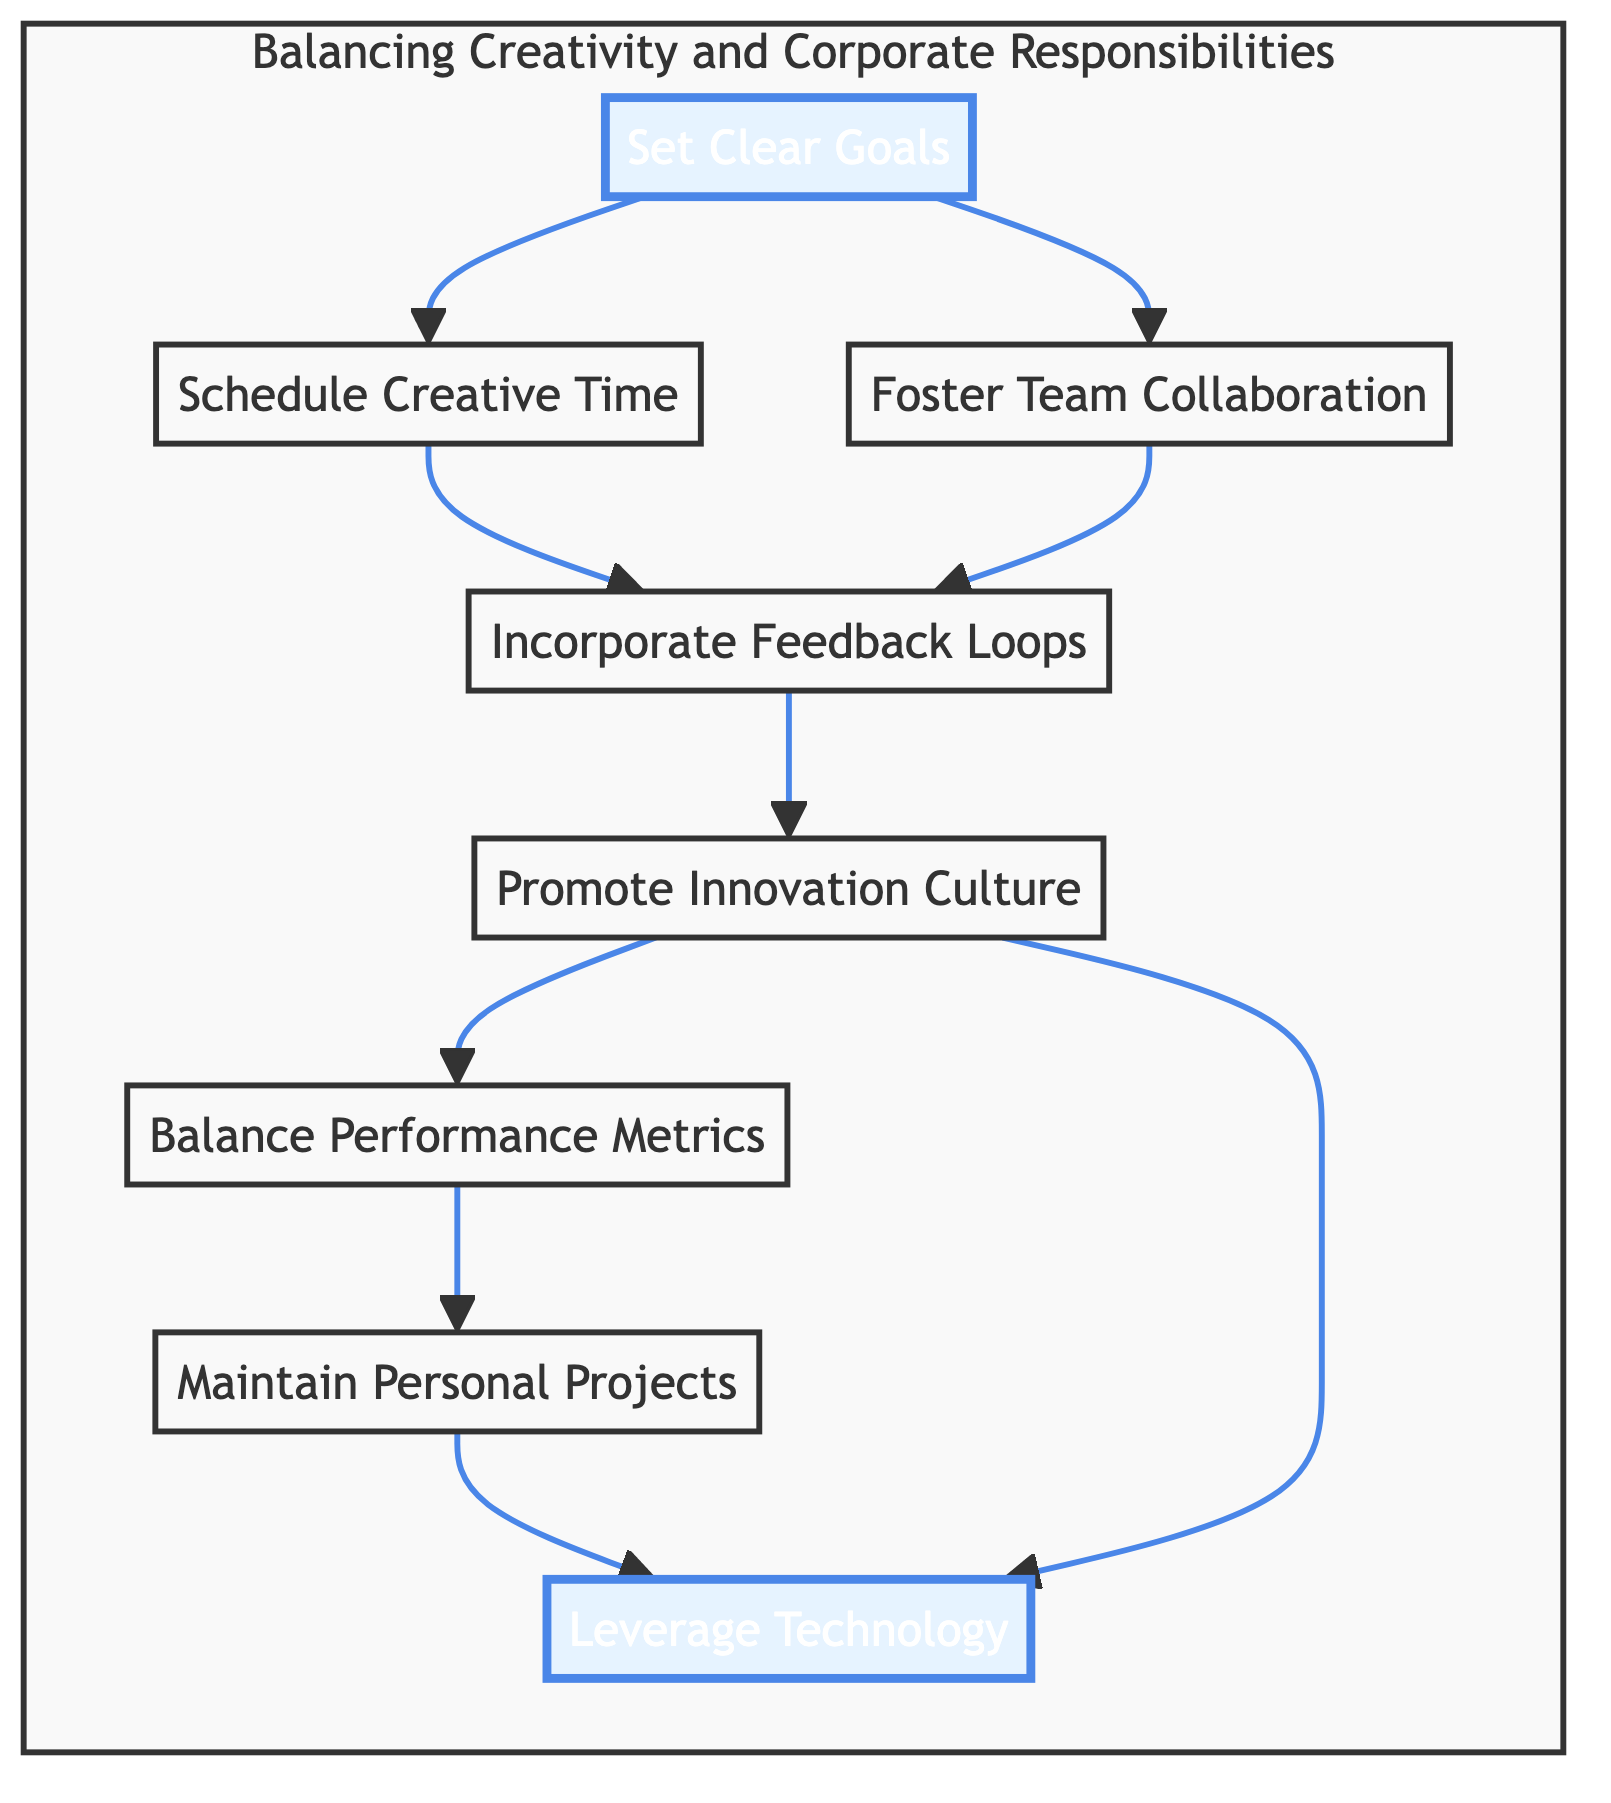What is the first step in the flow? The first step in the flow chart is represented by node A, which is labeled "Set Clear Goals." It is the starting point for balancing creativity and corporate responsibilities, which is indicative of planning before other actions take place.
Answer: Set Clear Goals How many nodes are in the diagram? Counting the distinct nodes in the diagram, we find a total of 8 nodes, each representing a different strategy for balancing creativity and corporate responsibilities.
Answer: 8 What follows after "Schedule Creative Time"? In the flow chart, the node that directly follows "Schedule Creative Time," which is node B, is "Incorporate Feedback Loops," indicating that scheduling creative time leads into the feedback process.
Answer: Incorporate Feedback Loops Which nodes have an outgoing connection to "Leverage Technology"? The nodes that have an outgoing connection to "Leverage Technology," which is node H, are "Promote Innovation Culture" and "Maintain Personal Projects." This means both of these steps lead to leveraging technology as a strategy.
Answer: Promote Innovation Culture, Maintain Personal Projects Which step comes before "Balance Performance Metrics"? The step that comes before "Balance Performance Metrics," which is node F, is "Promote Innovation Culture," represented by node E, indicating that fostering innovation happens prior to balancing metrics.
Answer: Promote Innovation Culture What is the total number of directed edges in the flow chart? By analyzing the connections between nodes in the flow chart, we can count 7 directed edges, showing the paths from one strategy to another in the process of balancing creativity with corporate responsibilities.
Answer: 7 Are there any nodes that link to "Incorporate Feedback Loops"? There are two nodes that link directly to "Incorporate Feedback Loops," which are "Schedule Creative Time" (node B) and "Foster Team Collaboration" (node C). This indicates that both scheduling and collaboration lead to the need for incorporating feedback.
Answer: Schedule Creative Time, Foster Team Collaboration In which part of the chart do personal projects fit? Personal projects are represented by node G, which is "Maintain Personal Projects." It fits towards the end of the flow, indicating that maintaining personal projects sustains creative passion after balancing prior responsibilities.
Answer: Maintain Personal Projects 